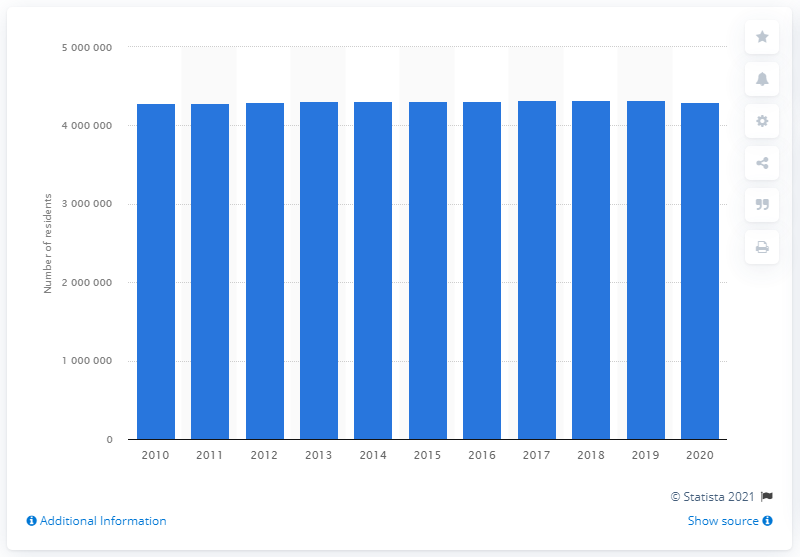Point out several critical features in this image. In 2020, the population of the Detroit-Warren-Dearborn area was approximately 4,291,281. In the previous year, the estimated number of people living in the Detroit-Warren-Dearborn area was 429,1281. 